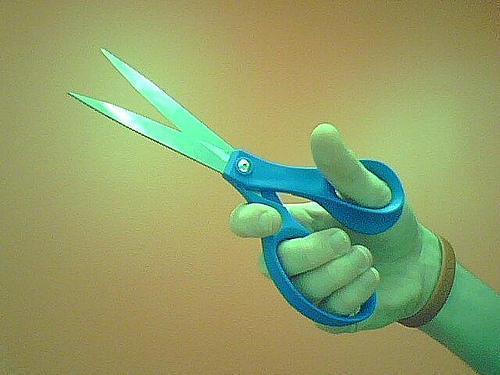How many brown horses are in the grass?
Give a very brief answer. 0. 